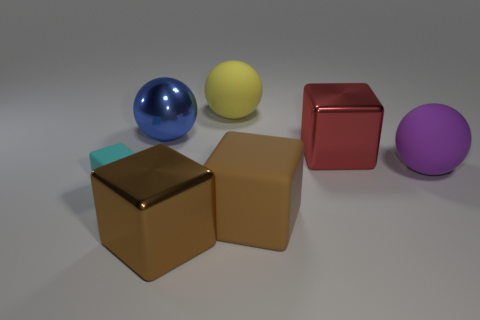Subtract all red metal blocks. How many blocks are left? 3 Subtract all spheres. How many objects are left? 4 Add 3 big purple rubber objects. How many objects exist? 10 Add 5 brown rubber things. How many brown rubber things are left? 6 Add 2 tiny purple spheres. How many tiny purple spheres exist? 2 Subtract all blue spheres. How many spheres are left? 2 Subtract 0 gray cubes. How many objects are left? 7 Subtract 3 spheres. How many spheres are left? 0 Subtract all red blocks. Subtract all red cylinders. How many blocks are left? 3 Subtract all yellow spheres. How many red cubes are left? 1 